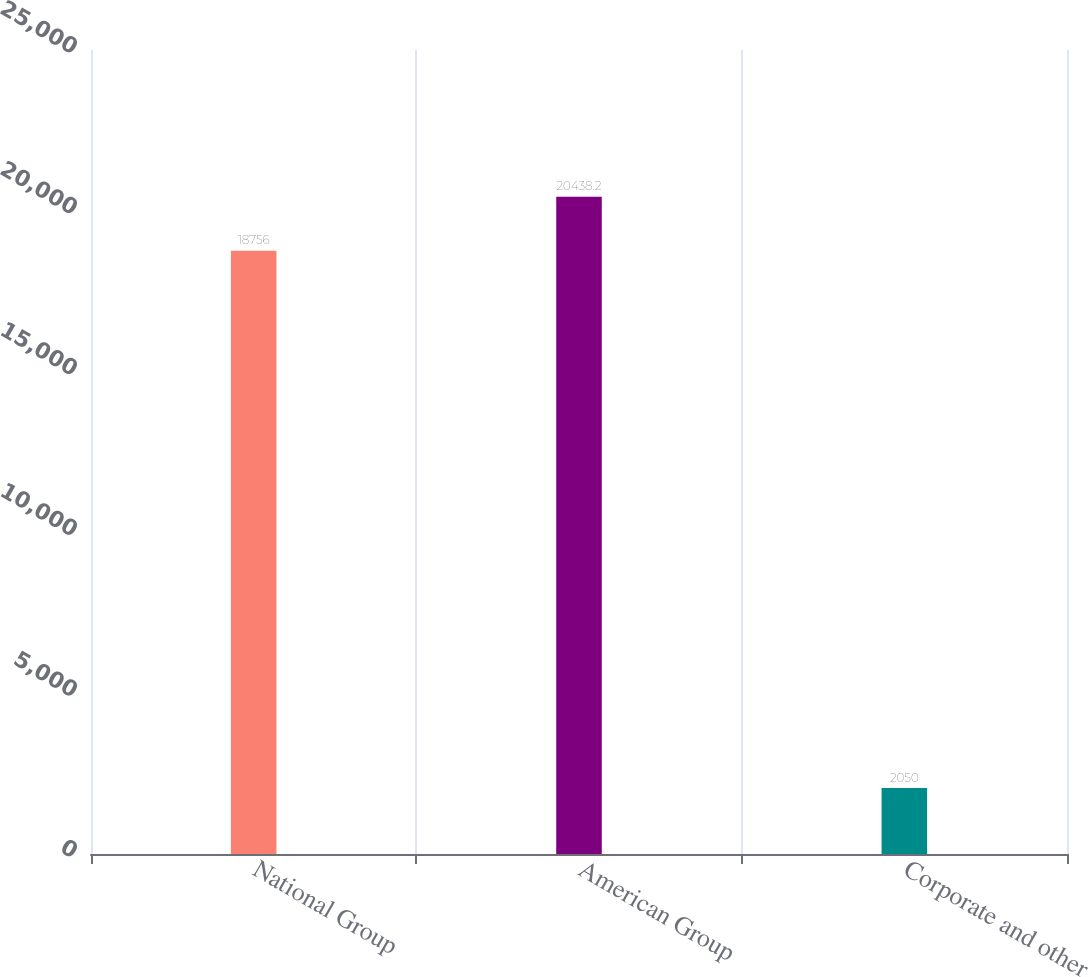<chart> <loc_0><loc_0><loc_500><loc_500><bar_chart><fcel>National Group<fcel>American Group<fcel>Corporate and other<nl><fcel>18756<fcel>20438.2<fcel>2050<nl></chart> 